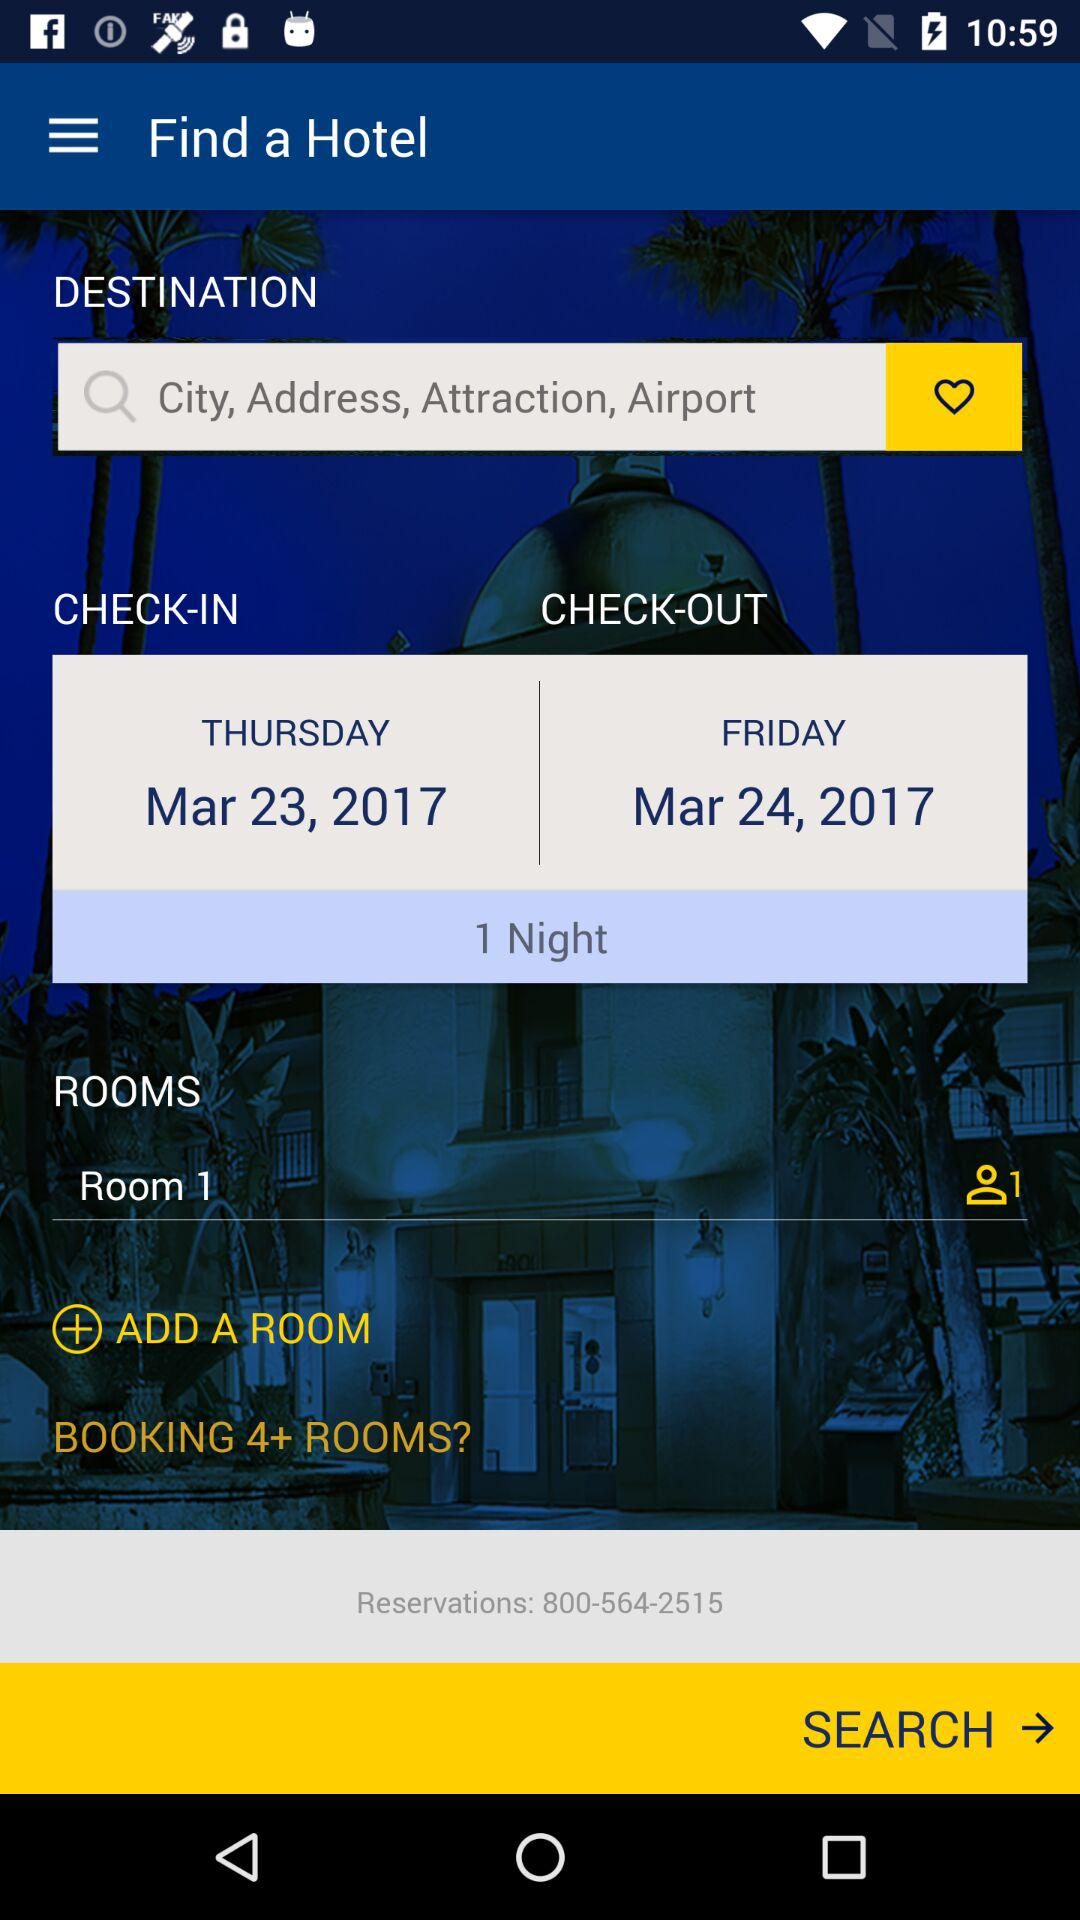What is the check in date? The check in date is March 23, 2017. 